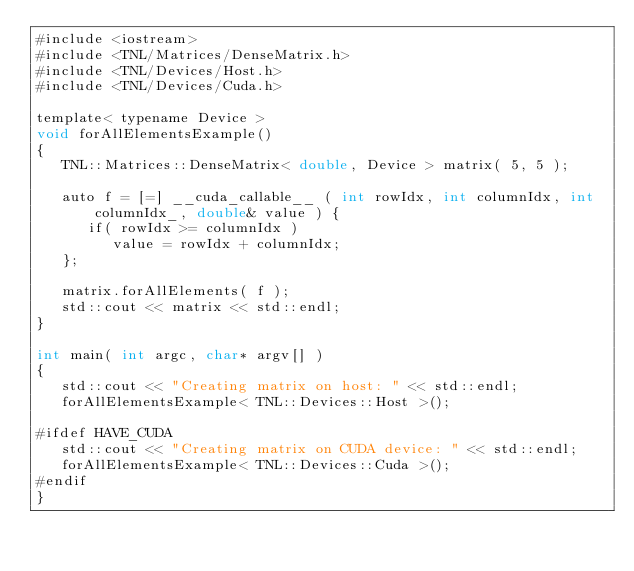<code> <loc_0><loc_0><loc_500><loc_500><_Cuda_>#include <iostream>
#include <TNL/Matrices/DenseMatrix.h>
#include <TNL/Devices/Host.h>
#include <TNL/Devices/Cuda.h>

template< typename Device >
void forAllElementsExample()
{
   TNL::Matrices::DenseMatrix< double, Device > matrix( 5, 5 );

   auto f = [=] __cuda_callable__ ( int rowIdx, int columnIdx, int columnIdx_, double& value ) {
      if( rowIdx >= columnIdx )
         value = rowIdx + columnIdx;
   };

   matrix.forAllElements( f );
   std::cout << matrix << std::endl;
}

int main( int argc, char* argv[] )
{
   std::cout << "Creating matrix on host: " << std::endl;
   forAllElementsExample< TNL::Devices::Host >();

#ifdef HAVE_CUDA
   std::cout << "Creating matrix on CUDA device: " << std::endl;
   forAllElementsExample< TNL::Devices::Cuda >();
#endif
}
</code> 